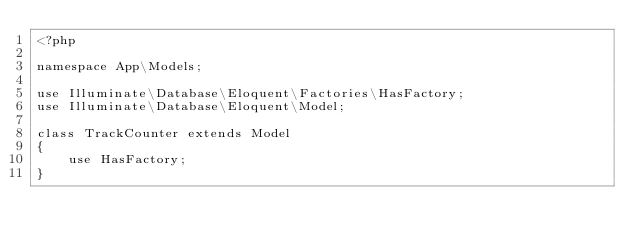Convert code to text. <code><loc_0><loc_0><loc_500><loc_500><_PHP_><?php

namespace App\Models;

use Illuminate\Database\Eloquent\Factories\HasFactory;
use Illuminate\Database\Eloquent\Model;

class TrackCounter extends Model
{
    use HasFactory;
}
</code> 